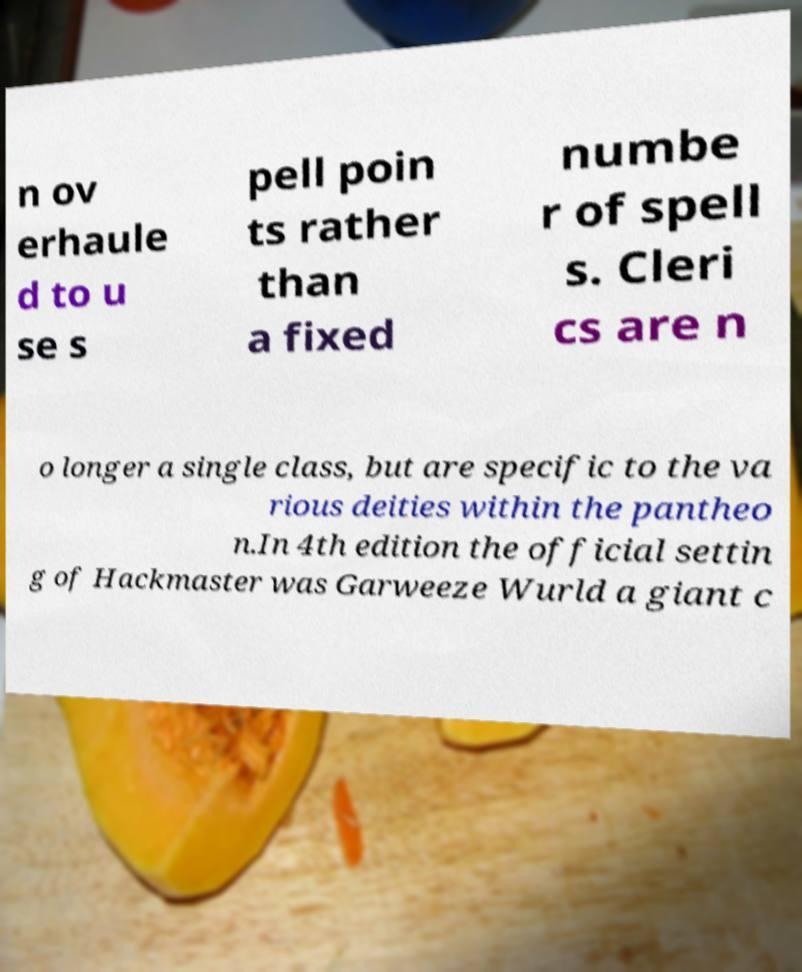Please read and relay the text visible in this image. What does it say? n ov erhaule d to u se s pell poin ts rather than a fixed numbe r of spell s. Cleri cs are n o longer a single class, but are specific to the va rious deities within the pantheo n.In 4th edition the official settin g of Hackmaster was Garweeze Wurld a giant c 